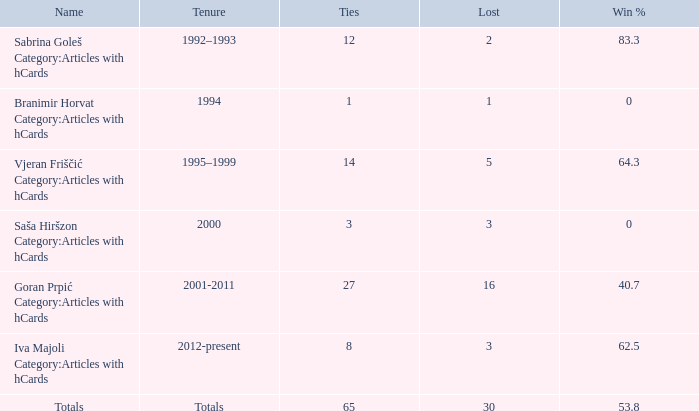How many ties have the name "totals" and a loss greater than 30? 0.0. 